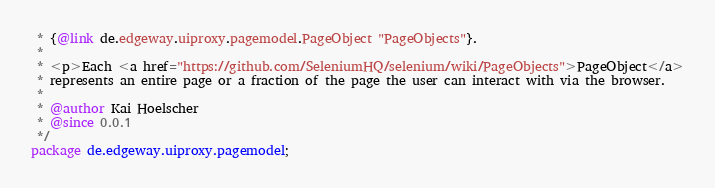Convert code to text. <code><loc_0><loc_0><loc_500><loc_500><_Java_> * {@link de.edgeway.uiproxy.pagemodel.PageObject "PageObjects"}.
 *
 * <p>Each <a href="https://github.com/SeleniumHQ/selenium/wiki/PageObjects">PageObject</a>
 * represents an entire page or a fraction of the page the user can interact with via the browser.
 *
 * @author Kai Hoelscher
 * @since 0.0.1
 */
package de.edgeway.uiproxy.pagemodel;

</code> 